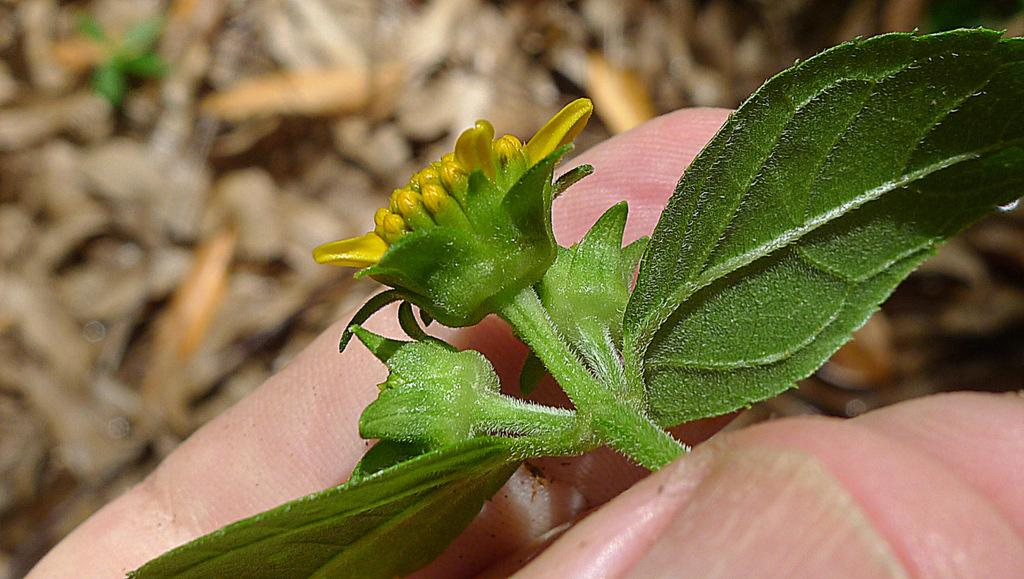What can be seen in the image that belongs to a person? There is a person's hand in the image. What is the hand holding? The hand is holding a flower. Can you describe the flower in the image? The flower has leaves. What type of card is being used to start the engine in the image? There is no card or engine present in the image; it features a person's hand holding a flower with leaves. 